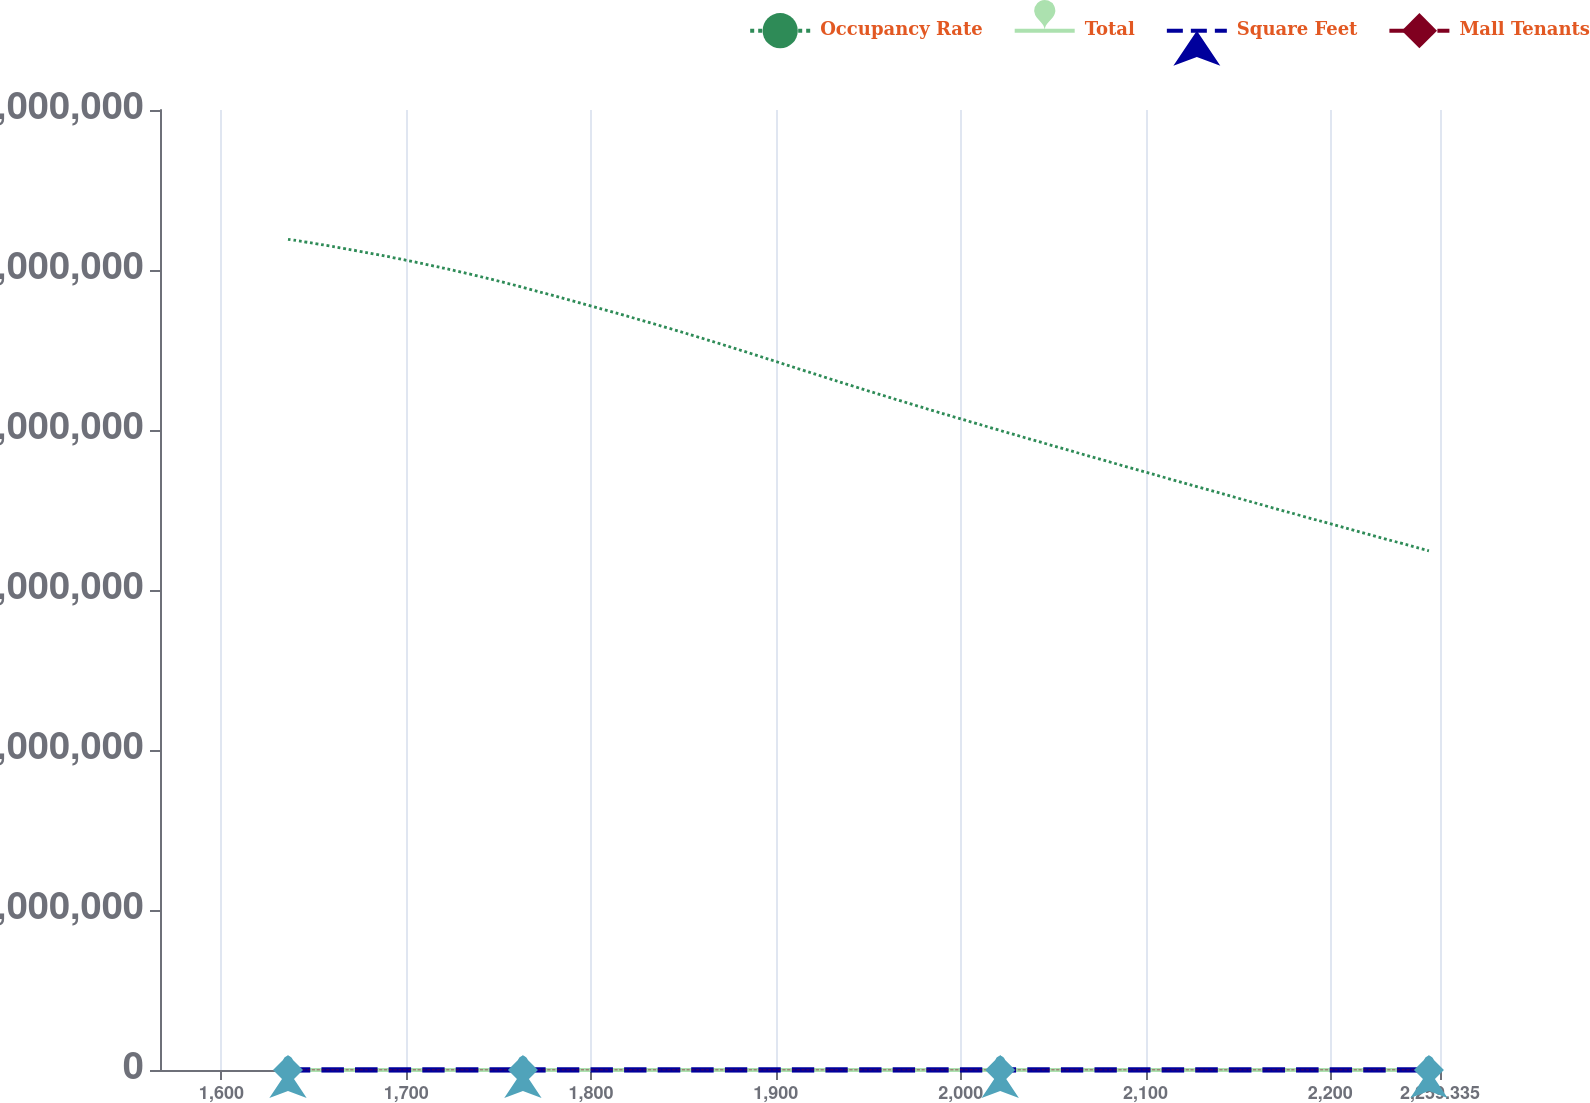Convert chart. <chart><loc_0><loc_0><loc_500><loc_500><line_chart><ecel><fcel>Occupancy Rate<fcel>Total<fcel>Square Feet<fcel>Mall Tenants<nl><fcel>1636.04<fcel>5.19193e+06<fcel>109.09<fcel>33.19<fcel>18.67<nl><fcel>1763.14<fcel>4.89124e+06<fcel>112.46<fcel>36.67<fcel>15.66<nl><fcel>2021.39<fcel>3.99706e+06<fcel>77.19<fcel>38.61<fcel>17.21<nl><fcel>2253.35<fcel>3.24485e+06<fcel>80.56<fcel>34.31<fcel>18.11<nl><fcel>2328.59<fcel>2.81866e+06<fcel>96.89<fcel>27.86<fcel>16<nl></chart> 